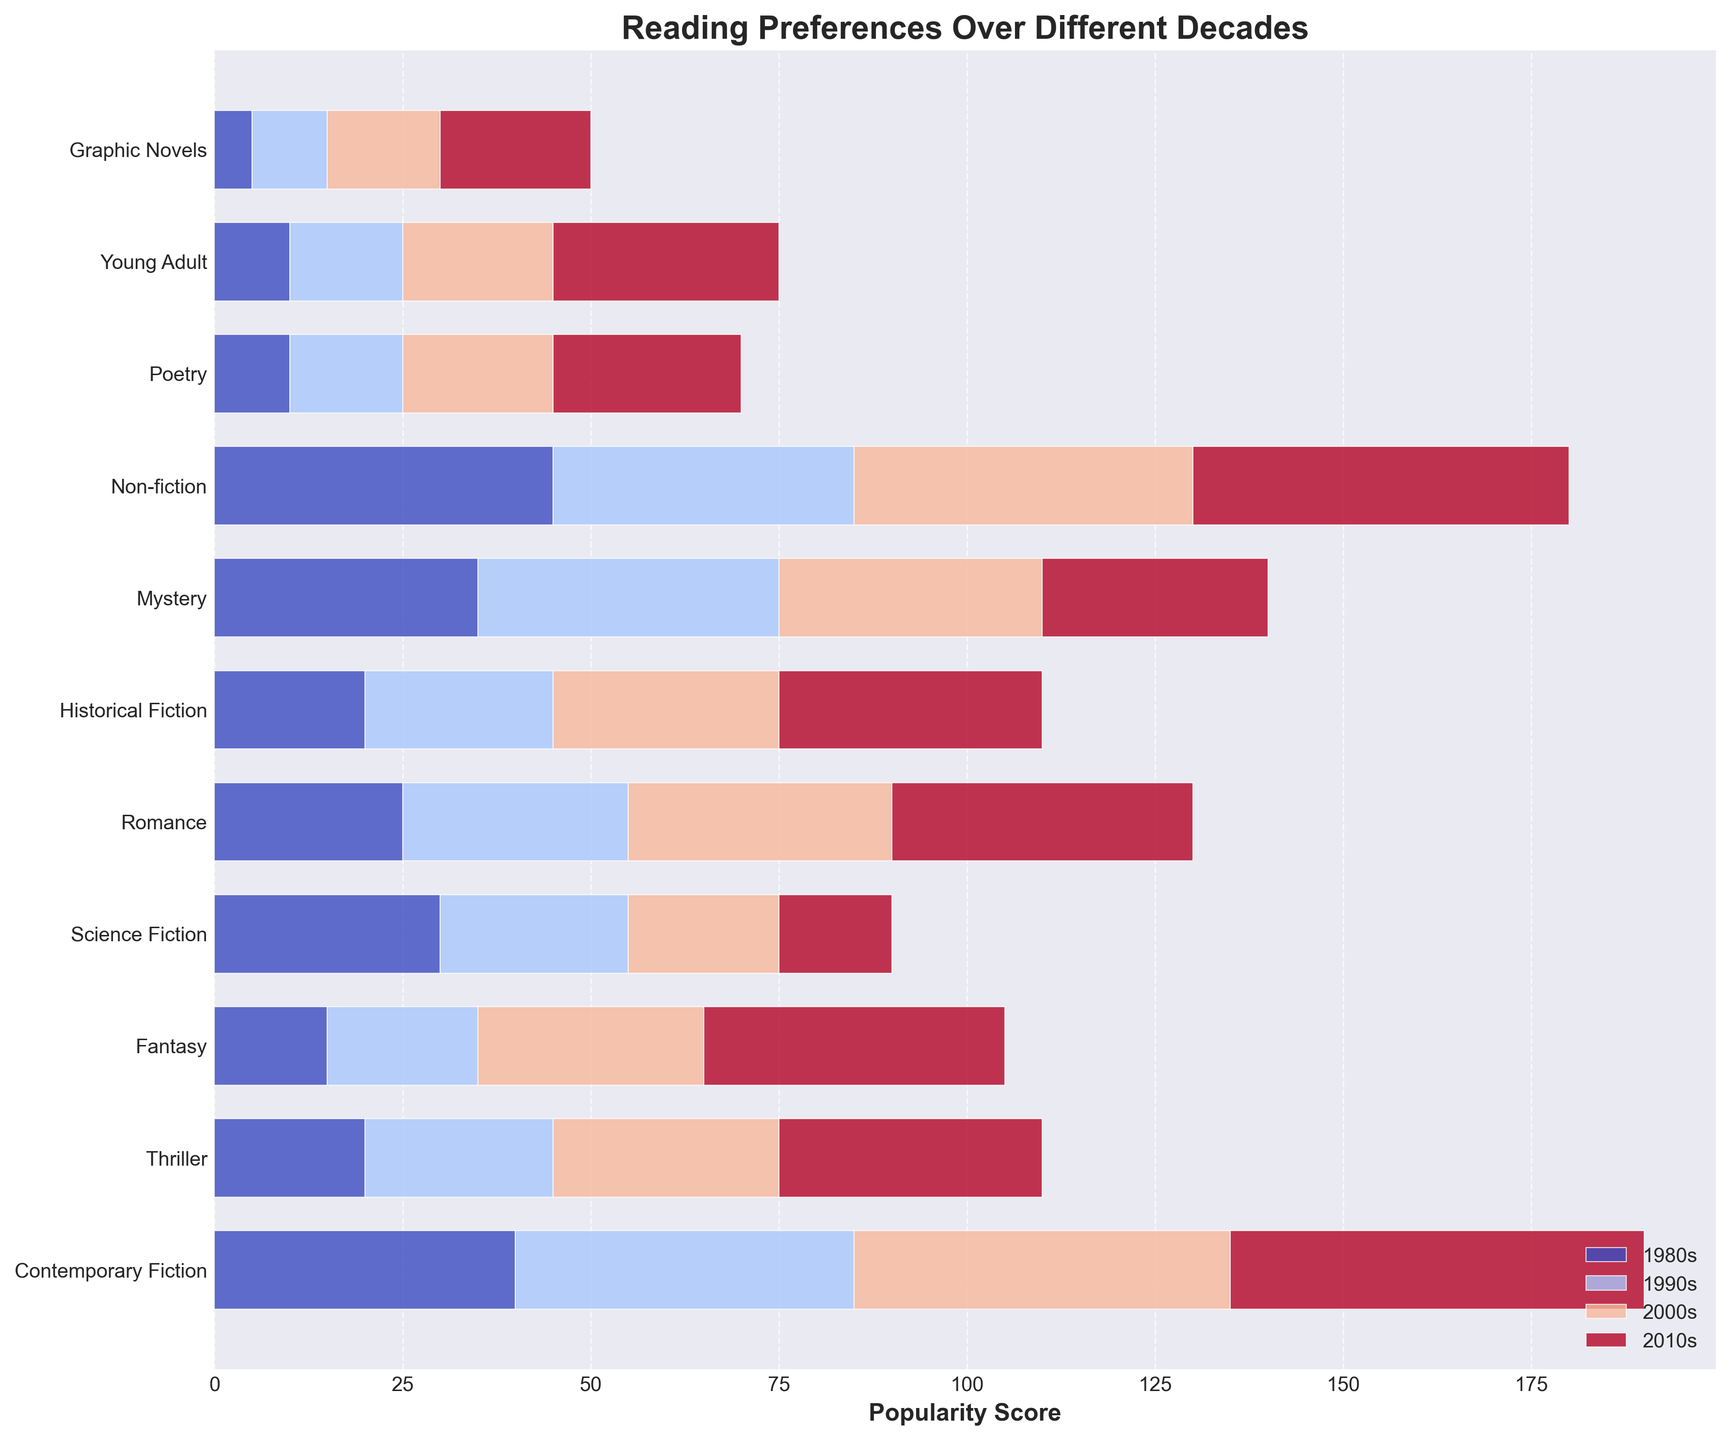Which genre had the highest popularity score in the 1980s? By looking at the bars labeled '1980s', we can see that Non-fiction had the highest bar reaching 45 units.
Answer: Non-fiction How did the popularity of Graphic Novels change from the 1980s to the 2010s? Comparing the lengths of the Graphic Novels bars across the decades, the value grew from 5 in the 1980s to 20 in the 2010s.
Answer: Increased Which decade saw the largest increase in popularity for Fantasy? By observing the difference in bar heights, the greatest increment for Fantasy was from the 2000s to the 2010s where it increased by 10 units (from 30 to 40).
Answer: 2010s What is the total combined popularity score for Mystery across all decades? Summing up the values for Mystery in the four decades: 35 + 40 + 35 + 30 = 140.
Answer: 140 Is Romance more popular than Contemporary Fiction in the 2010s? Comparing the bar lengths in the 2010s, Romance scores 40 while Contemporary Fiction scores 55. Hence, Romance is less popular.
Answer: No What was the popularity score difference between Thriller and Science Fiction in the 2000s? Subtracting the popularity scores of Science Fiction (20) from Thriller (30) in the 2000s: 30 - 20 = 10.
Answer: 10 Which genre has seen a consistent increase in popularity across all decades? By comparing bar heights over decades for each genre, Contemporary Fiction, Fantasy, Romance, and Young Adult consistently increased from the 1980s to the 2010s.
Answer: Contemporary Fiction, Fantasy, Romance, Young Adult How did the popularity of Non-fiction change in the 1990s compared to the 1980s? The bar for Non-fiction in the 1990s is shorter than the one in the 1980s, decreasing from 45 to 40, hence a decrease of 5 units.
Answer: Decreased by 5 Which genre had the least popularity score in the 1980s? Observing the bars labeled '1980s', Graphic Novels had the least score at 5 units.
Answer: Graphic Novels Are Poetry and Young Adult equally popular in the 2010s? Looking at the bar lengths in the 2010s, both Poetry and Young Adult have bars reaching 25 units.
Answer: Yes 